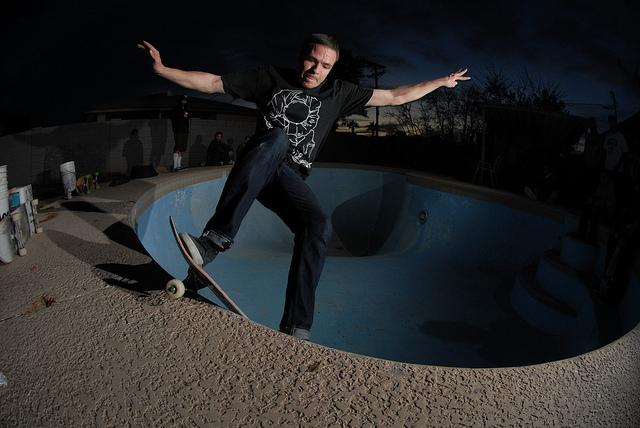Which foot is still touching the board?
Keep it brief. Right. What sport is he doing?
Write a very short answer. Skateboarding. What sport is being played?
Be succinct. Skateboarding. Is it day out?
Short answer required. No. Is this man flying on a skateboard?
Concise answer only. No. What color is the board?
Answer briefly. Black. What color are the man's clothes?
Quick response, please. Black. Is the skater going to fall?
Short answer required. No. How many skateboards are there?
Give a very brief answer. 1. What is the man doing?
Give a very brief answer. Skateboarding. What color is the man's hair?
Answer briefly. Brown. 